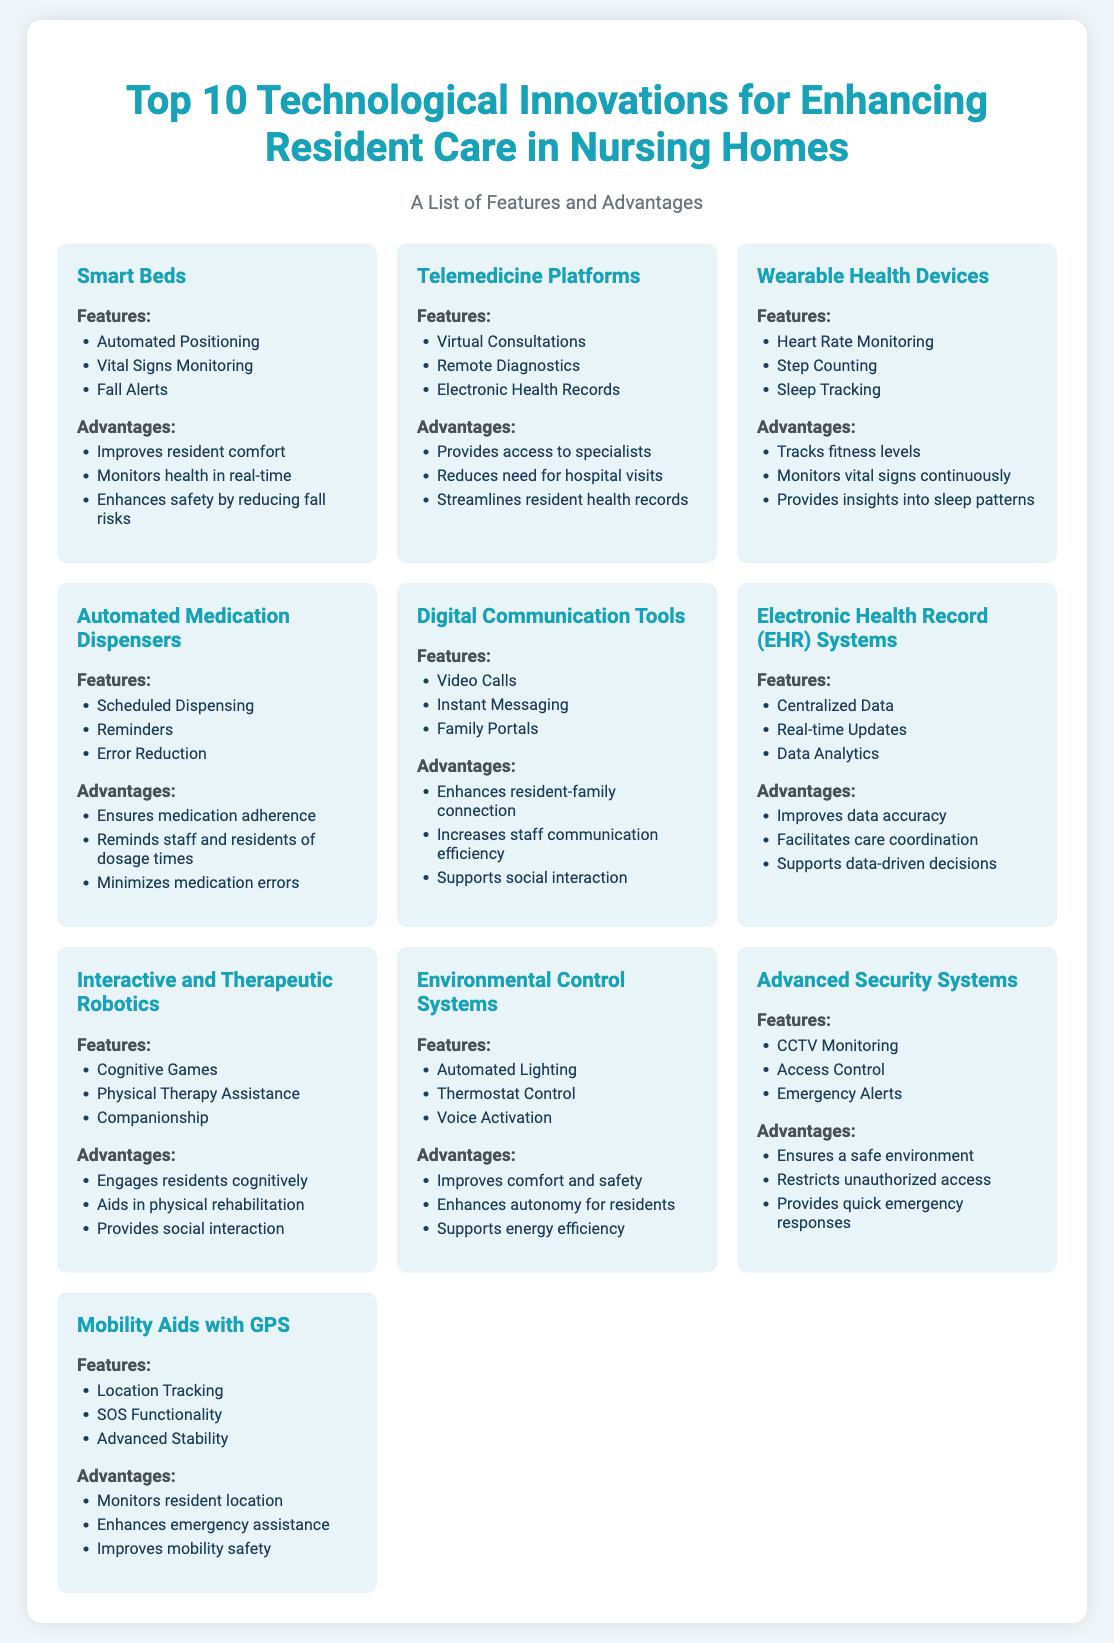What is the first innovation listed? The first innovation listed in the document is Smart Beds.
Answer: Smart Beds How many features does Telemedicine Platforms have? The Telemedicine Platforms have three features listed.
Answer: Three What advantage is associated with Wearable Health Devices? One of the advantages mentioned for Wearable Health Devices is that it monitors vital signs continuously.
Answer: Monitors vital signs continuously Which innovation includes 'Automated Lighting' as a feature? Automated Lighting is a feature of Environmental Control Systems.
Answer: Environmental Control Systems What is the main benefit of Advanced Security Systems? The main benefit stated is to ensure a safe environment.
Answer: Ensures a safe environment How many innovations are mentioned in total? There are ten technological innovations mentioned in the document.
Answer: Ten What type of consultation do Telemedicine Platforms offer? Telemedicine Platforms offer virtual consultations.
Answer: Virtual Consultations Which innovation aims to improve fitness levels? Wearable Health Devices aim to improve fitness levels.
Answer: Wearable Health Devices 